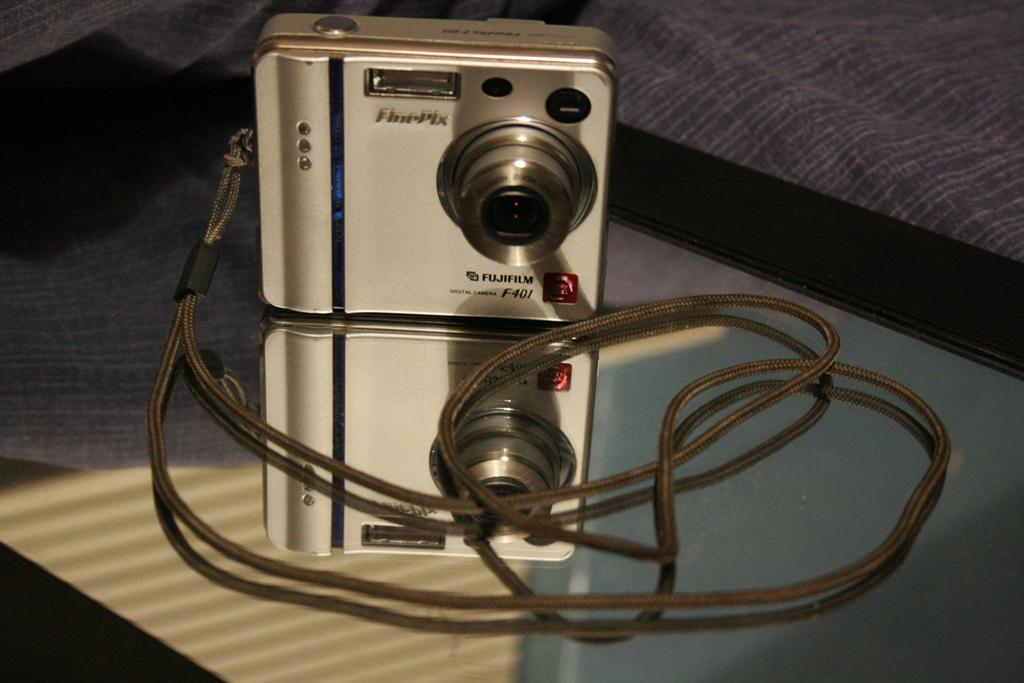What object is the main focus of the image? There is a silver color camera in the image. What is attached to the camera? The camera has a thread on it. Where is the camera placed? The camera is on a glass table. What is reflected on the glass table? There is a mirror image of the camera on the glass table. What can be seen in the background of the image? There is a sofa in the background of the image. What type of mountain is visible in the image? There is no mountain visible in the image; it features a silver color camera on a glass table. What activity is the camera engaged in within the image? The camera is not engaged in any activity within the image; it is simply placed on a glass table. 